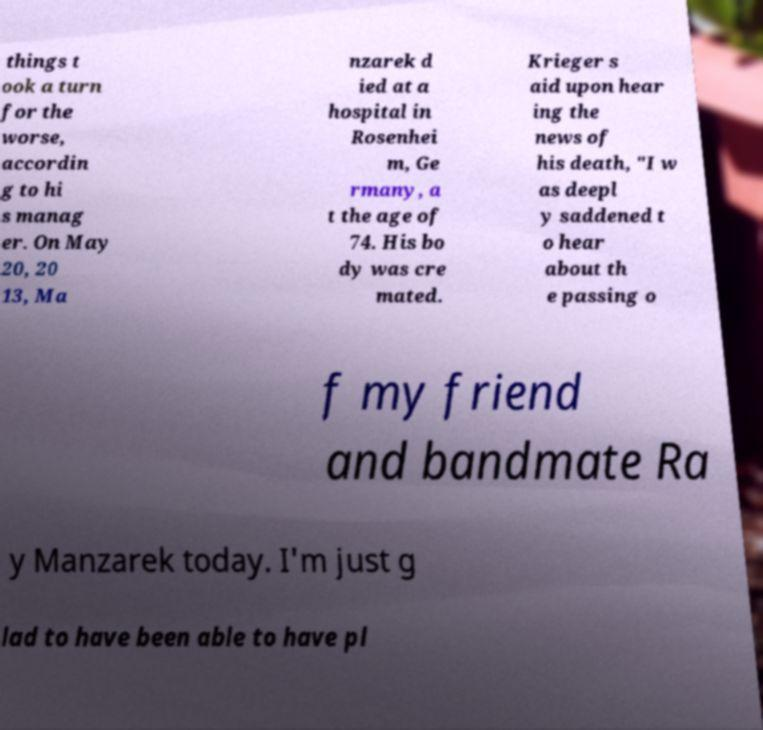I need the written content from this picture converted into text. Can you do that? things t ook a turn for the worse, accordin g to hi s manag er. On May 20, 20 13, Ma nzarek d ied at a hospital in Rosenhei m, Ge rmany, a t the age of 74. His bo dy was cre mated. Krieger s aid upon hear ing the news of his death, "I w as deepl y saddened t o hear about th e passing o f my friend and bandmate Ra y Manzarek today. I'm just g lad to have been able to have pl 